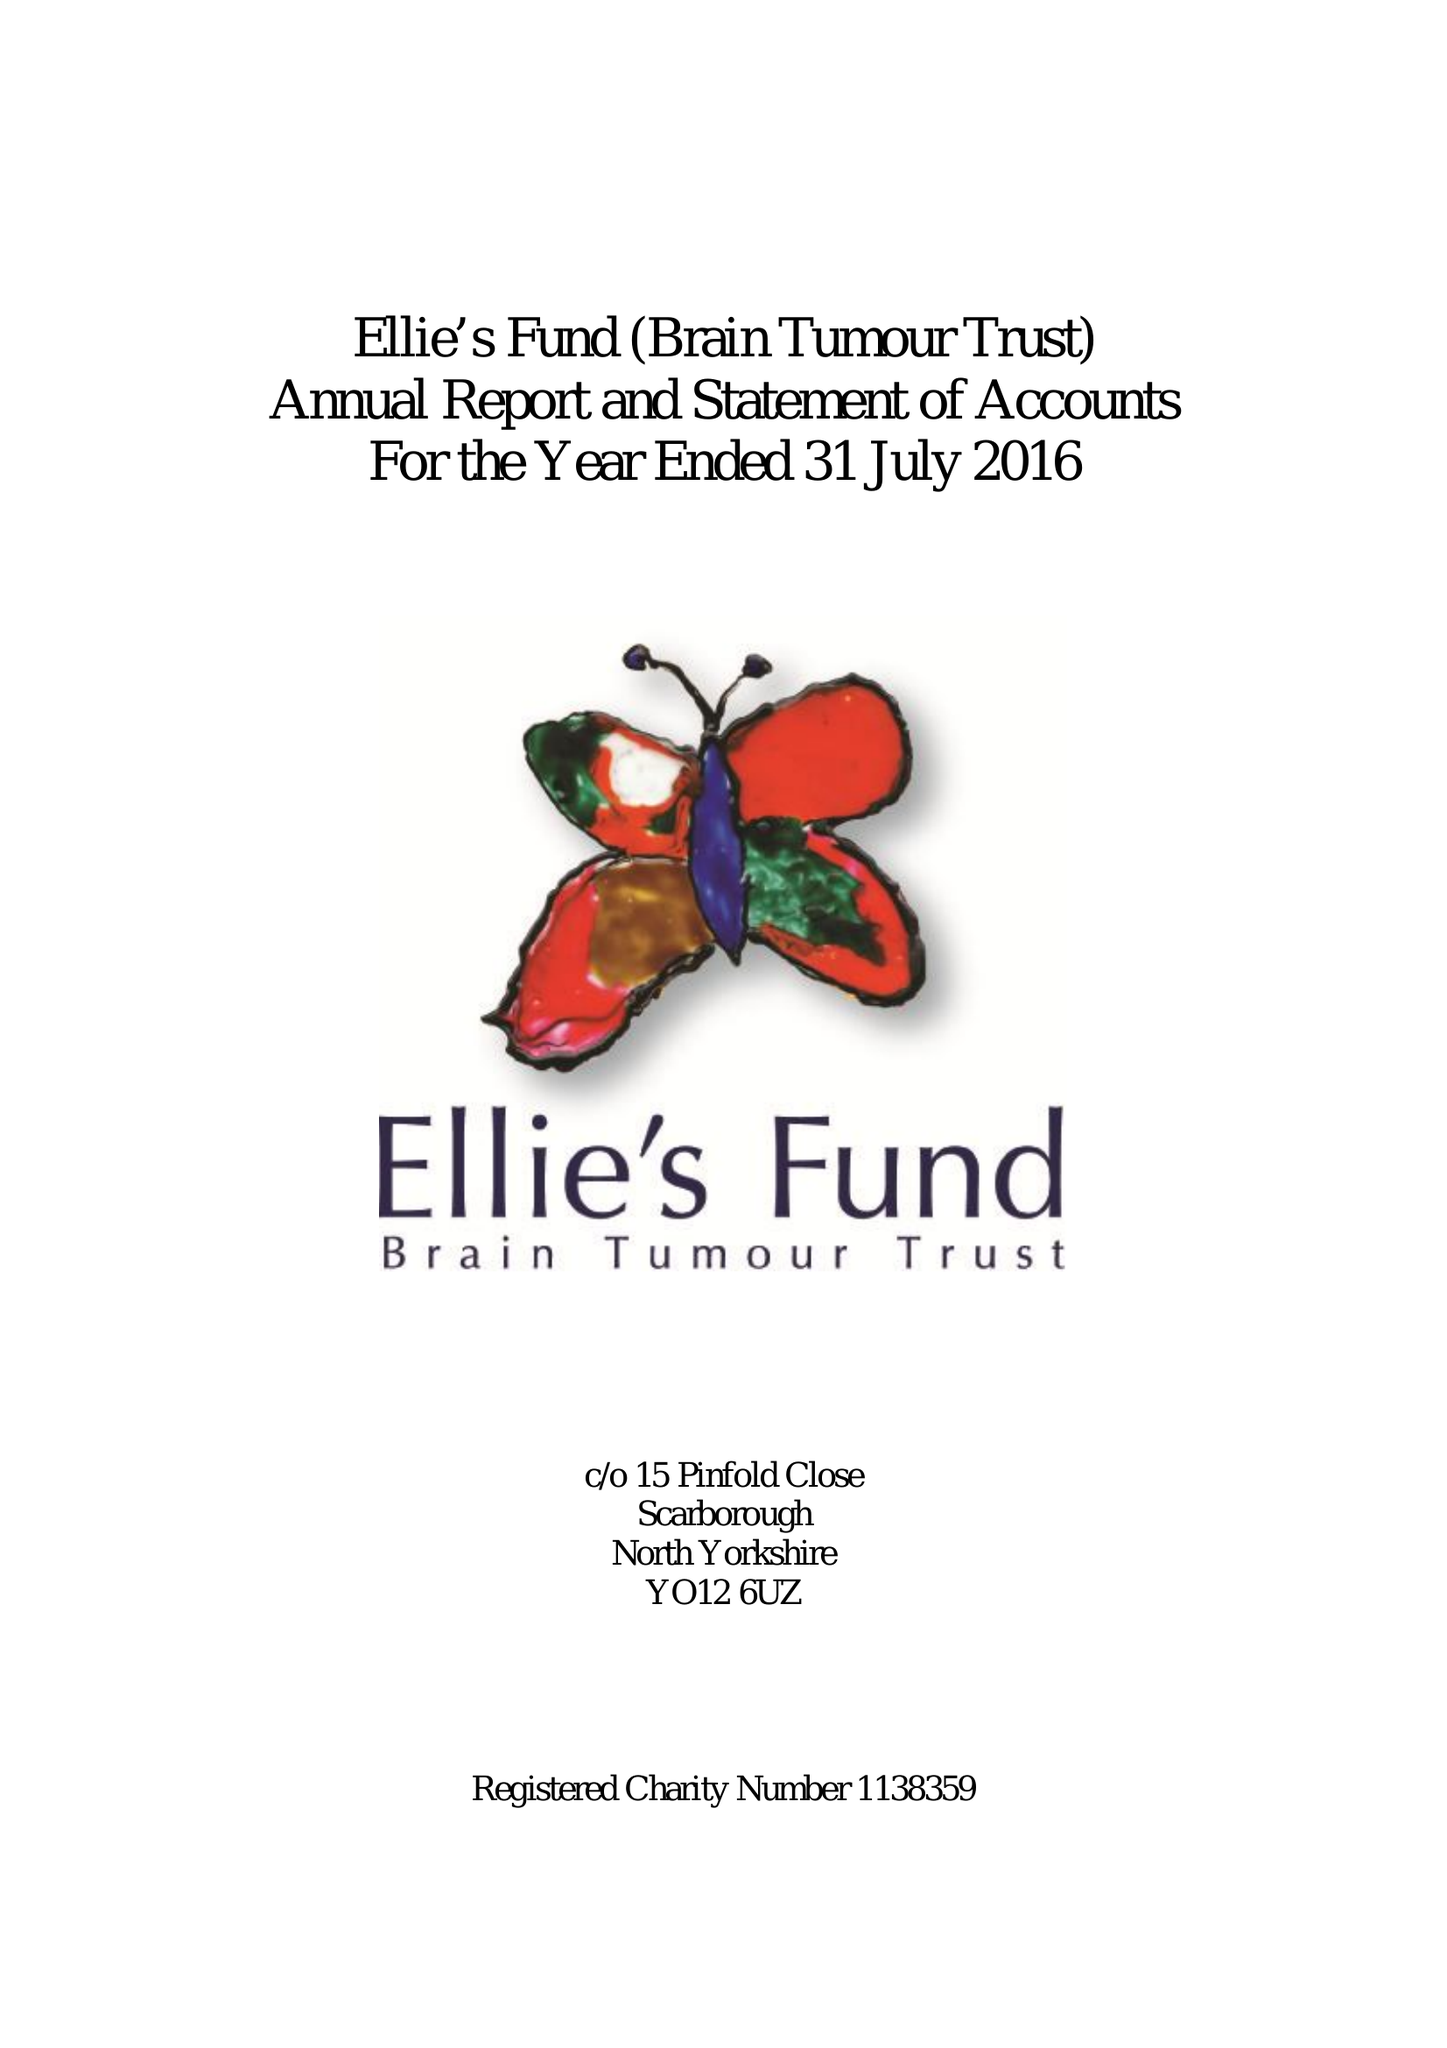What is the value for the income_annually_in_british_pounds?
Answer the question using a single word or phrase. 29901.00 